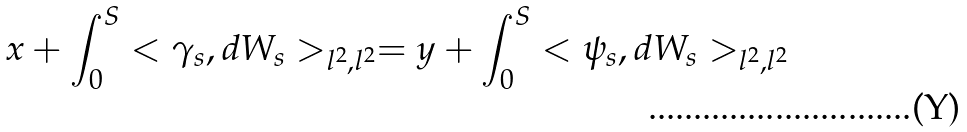Convert formula to latex. <formula><loc_0><loc_0><loc_500><loc_500>x + \int _ { 0 } ^ { S } < \gamma _ { s } , d W _ { s } > _ { l ^ { 2 } , l ^ { 2 } } = y + \int _ { 0 } ^ { S } < \psi _ { s } , d W _ { s } > _ { l ^ { 2 } , l ^ { 2 } }</formula> 